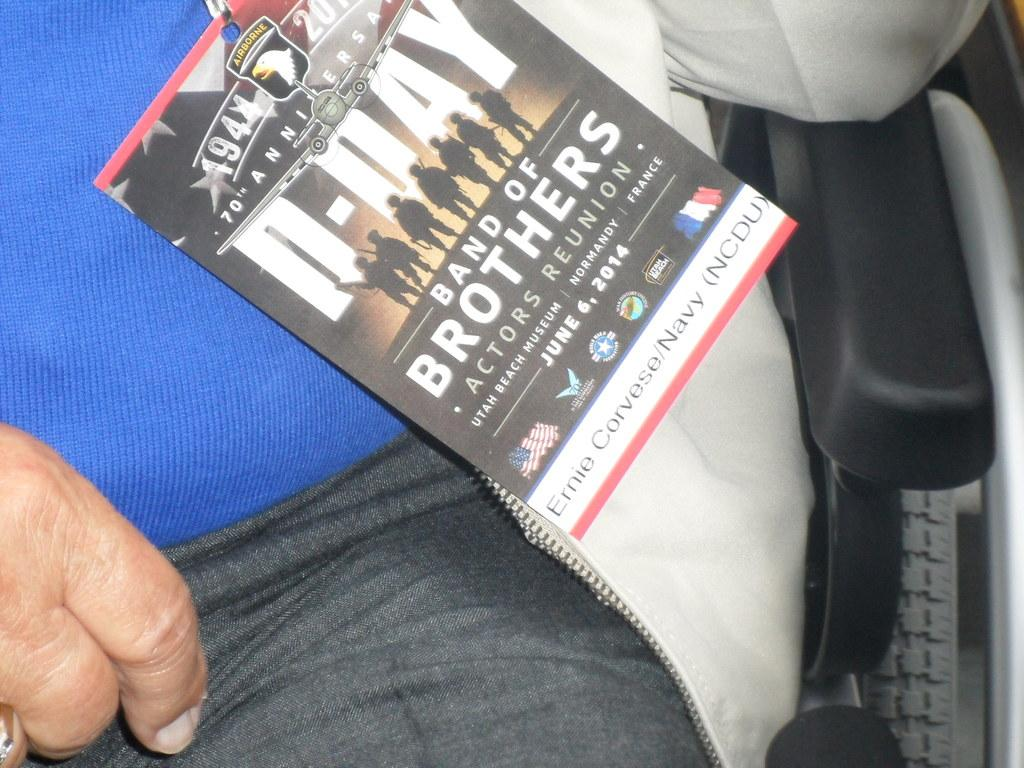Who or what is present in the image? There is a person in the image. What is the person doing in the image? The person is sitting on a chair. What else can be seen in the image besides the person? There is a paper in the image. Can you describe the paper in the image? The paper has pictures and text on it. What type of insect is crawling on the person's shoulder in the image? There is no insect present on the person's shoulder in the image. Can you tell me how many hens are visible in the image? There are no hens present in the image. 